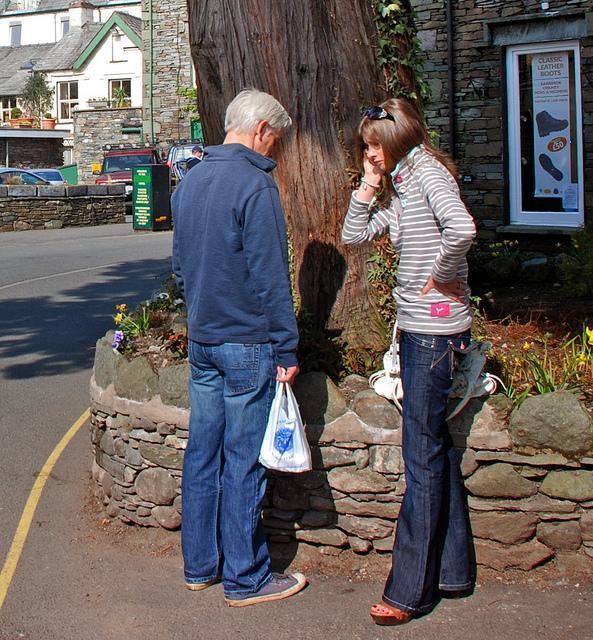How many people are in the photo?
Give a very brief answer. 2. How many chairs in this image do not have arms?
Give a very brief answer. 0. 